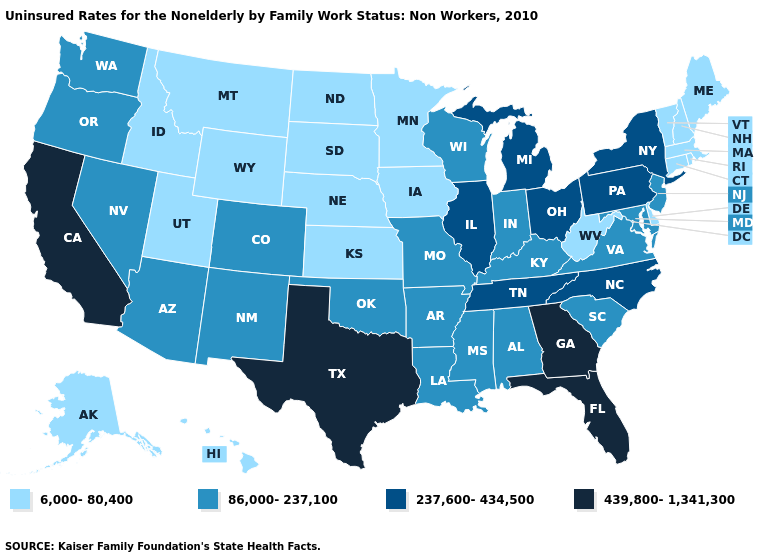What is the lowest value in the USA?
Be succinct. 6,000-80,400. Which states have the highest value in the USA?
Concise answer only. California, Florida, Georgia, Texas. Among the states that border Iowa , does South Dakota have the lowest value?
Short answer required. Yes. What is the highest value in the South ?
Quick response, please. 439,800-1,341,300. Name the states that have a value in the range 6,000-80,400?
Short answer required. Alaska, Connecticut, Delaware, Hawaii, Idaho, Iowa, Kansas, Maine, Massachusetts, Minnesota, Montana, Nebraska, New Hampshire, North Dakota, Rhode Island, South Dakota, Utah, Vermont, West Virginia, Wyoming. Does Delaware have a higher value than Texas?
Give a very brief answer. No. What is the value of Virginia?
Short answer required. 86,000-237,100. Among the states that border Illinois , does Iowa have the highest value?
Be succinct. No. Does Tennessee have a higher value than New York?
Write a very short answer. No. Which states have the highest value in the USA?
Answer briefly. California, Florida, Georgia, Texas. What is the highest value in the South ?
Short answer required. 439,800-1,341,300. Does Pennsylvania have the lowest value in the Northeast?
Keep it brief. No. Does Montana have the lowest value in the West?
Answer briefly. Yes. What is the value of Florida?
Answer briefly. 439,800-1,341,300. What is the highest value in the West ?
Keep it brief. 439,800-1,341,300. 